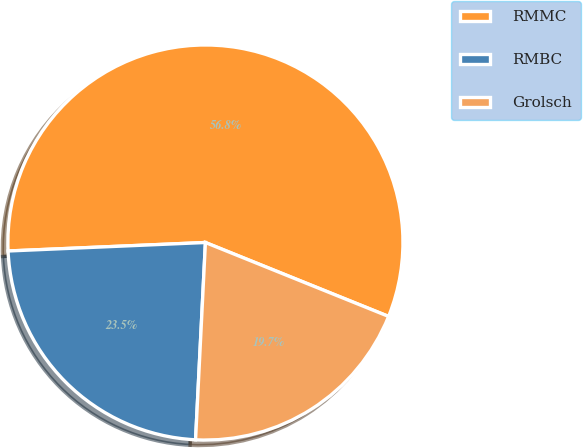<chart> <loc_0><loc_0><loc_500><loc_500><pie_chart><fcel>RMMC<fcel>RMBC<fcel>Grolsch<nl><fcel>56.79%<fcel>23.52%<fcel>19.69%<nl></chart> 